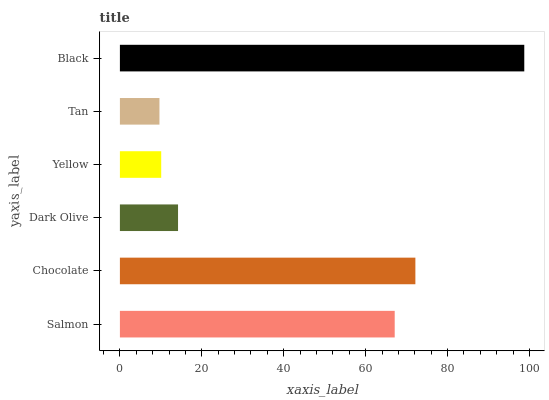Is Tan the minimum?
Answer yes or no. Yes. Is Black the maximum?
Answer yes or no. Yes. Is Chocolate the minimum?
Answer yes or no. No. Is Chocolate the maximum?
Answer yes or no. No. Is Chocolate greater than Salmon?
Answer yes or no. Yes. Is Salmon less than Chocolate?
Answer yes or no. Yes. Is Salmon greater than Chocolate?
Answer yes or no. No. Is Chocolate less than Salmon?
Answer yes or no. No. Is Salmon the high median?
Answer yes or no. Yes. Is Dark Olive the low median?
Answer yes or no. Yes. Is Chocolate the high median?
Answer yes or no. No. Is Tan the low median?
Answer yes or no. No. 